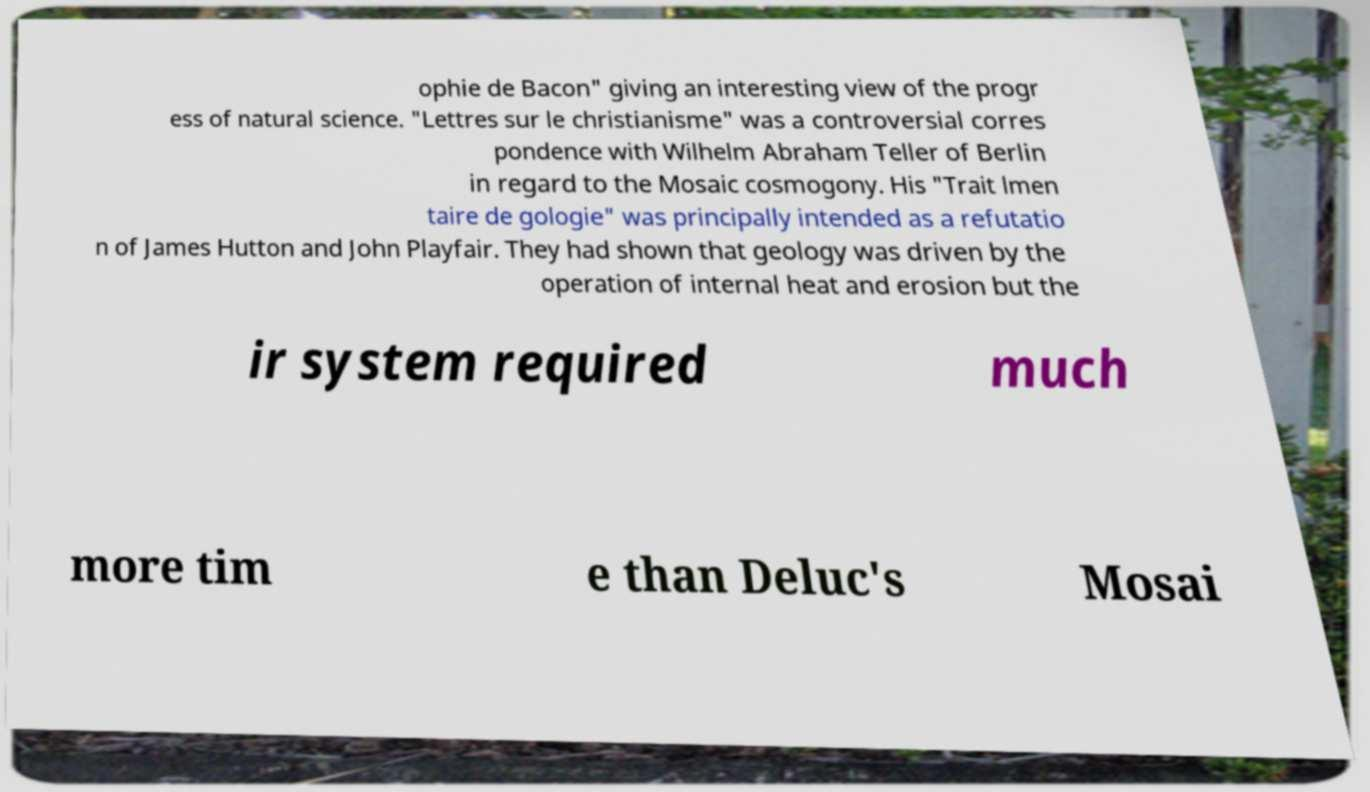Can you read and provide the text displayed in the image?This photo seems to have some interesting text. Can you extract and type it out for me? ophie de Bacon" giving an interesting view of the progr ess of natural science. "Lettres sur le christianisme" was a controversial corres pondence with Wilhelm Abraham Teller of Berlin in regard to the Mosaic cosmogony. His "Trait lmen taire de gologie" was principally intended as a refutatio n of James Hutton and John Playfair. They had shown that geology was driven by the operation of internal heat and erosion but the ir system required much more tim e than Deluc's Mosai 